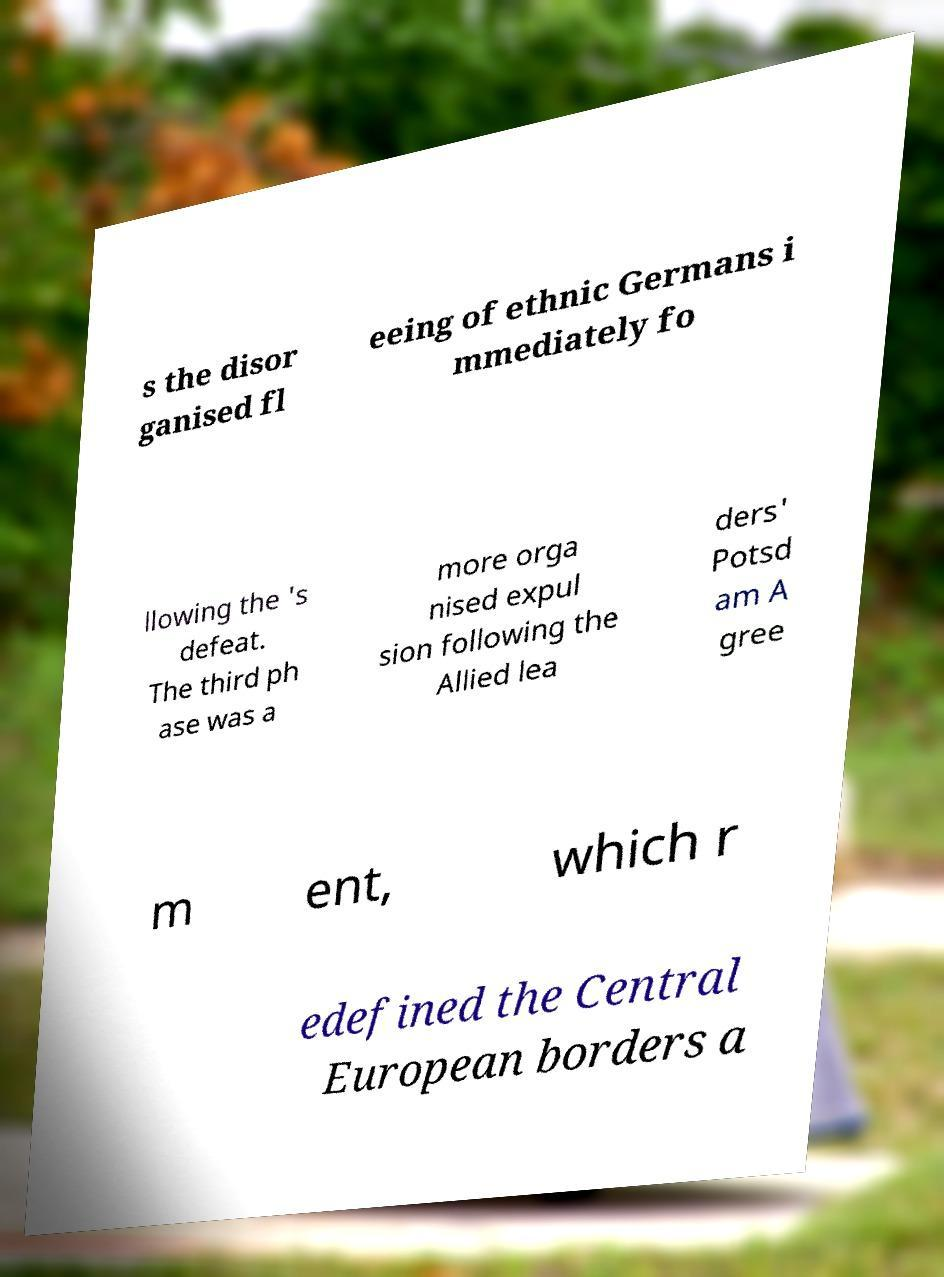Please identify and transcribe the text found in this image. s the disor ganised fl eeing of ethnic Germans i mmediately fo llowing the 's defeat. The third ph ase was a more orga nised expul sion following the Allied lea ders' Potsd am A gree m ent, which r edefined the Central European borders a 